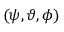Convert formula to latex. <formula><loc_0><loc_0><loc_500><loc_500>( \psi , \vartheta , \phi )</formula> 